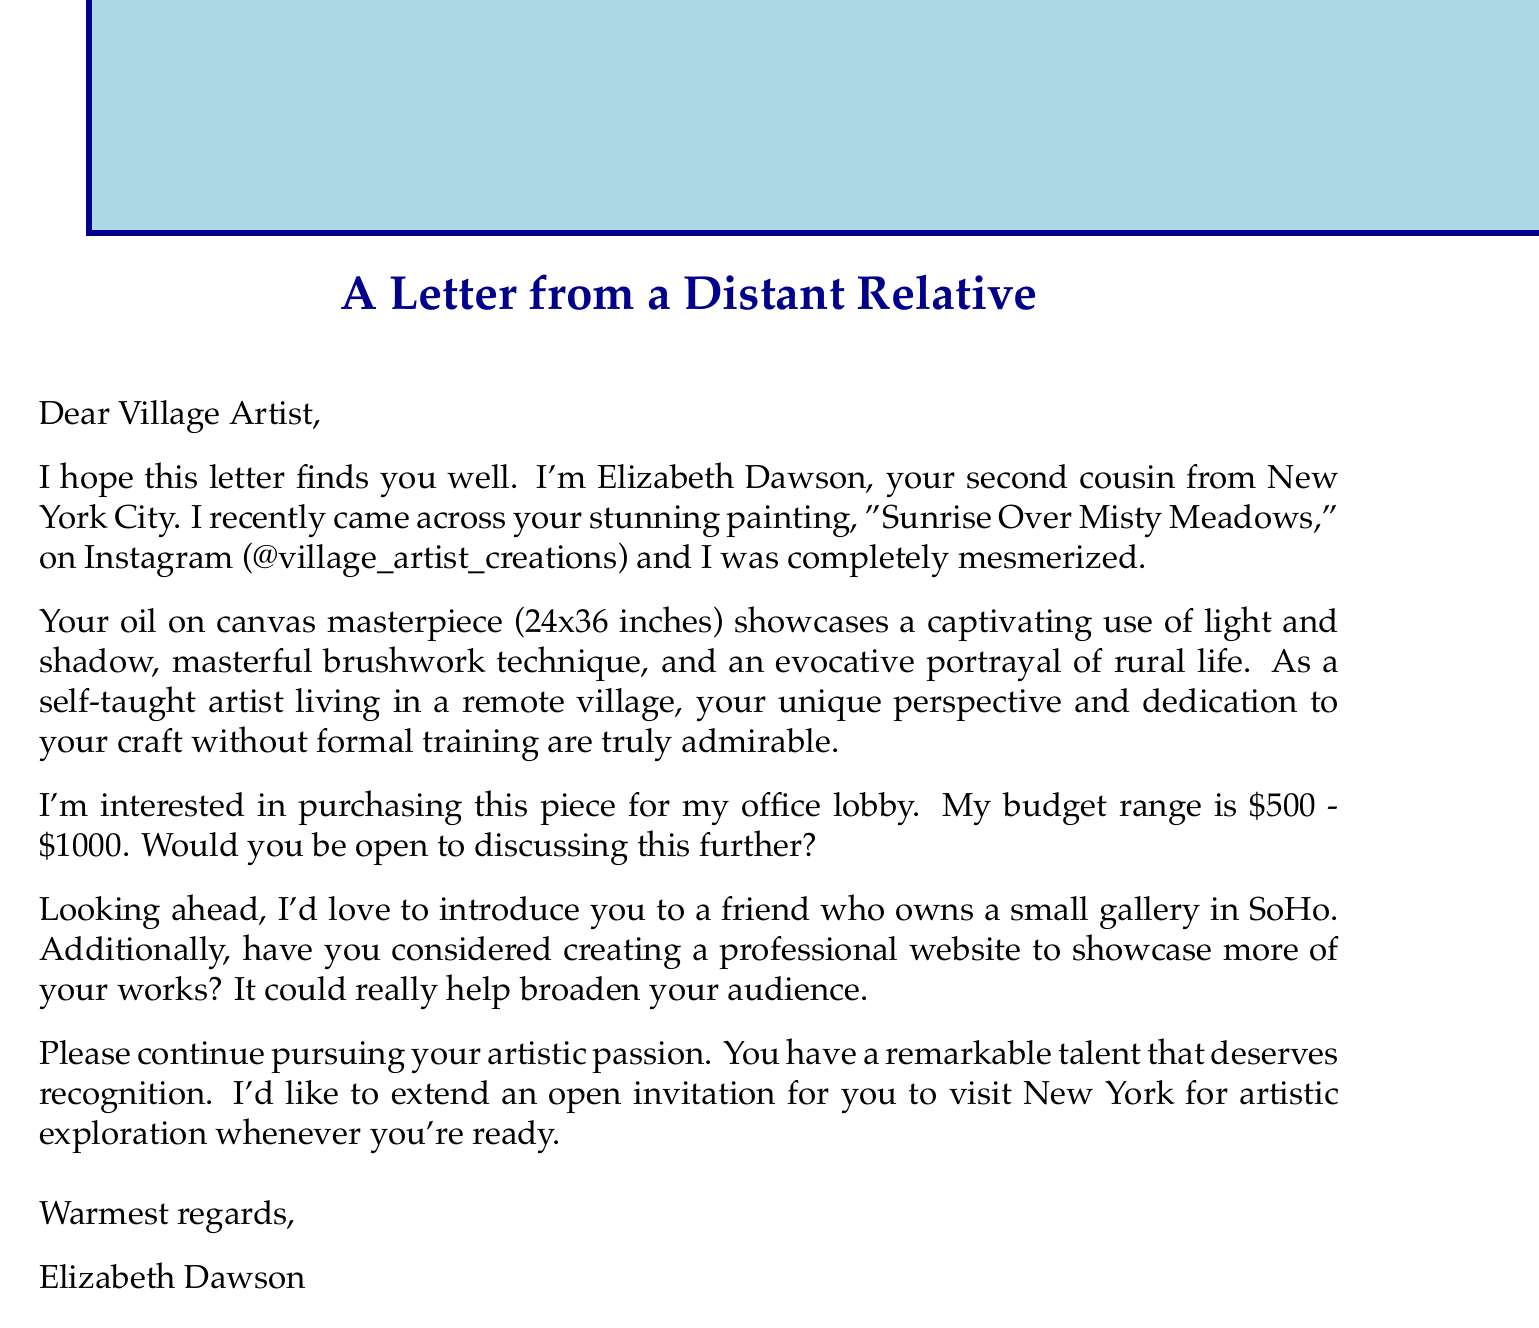what is the name of the sender? The name of the sender is mentioned in the document as Elizabeth Dawson.
Answer: Elizabeth Dawson what is the relationship of the sender to the artist? The document states that the sender is the artist's second cousin.
Answer: Second cousin what is the size of the painting? The size of the painting is specified as 24x36 inches.
Answer: 24x36 inches what is the budget range mentioned for purchasing the painting? The budget range for purchasing the painting is stated as $500 - $1000.
Answer: $500 - $1000 what is the title of the painting? The title of the painting referred to in the document is "Sunrise Over Misty Meadows."
Answer: Sunrise Over Misty Meadows why does the sender admire the artist? The sender admires the artist for their dedication to craft without formal training and their unique perspective from a remote village.
Answer: Dedication to craft and unique perspective where did the sender discover the painting? The sender discovered the painting on Instagram, specifically on the account @village_artist_creations.
Answer: Instagram what future opportunity does the sender offer the artist? The sender offers to introduce the artist to a friend who owns a small gallery in SoHo.
Answer: Introduce to a friend with a gallery what does the sender suggest the artist consider for showcasing their works? The sender suggests that the artist consider creating a professional website to showcase more works.
Answer: A professional website 